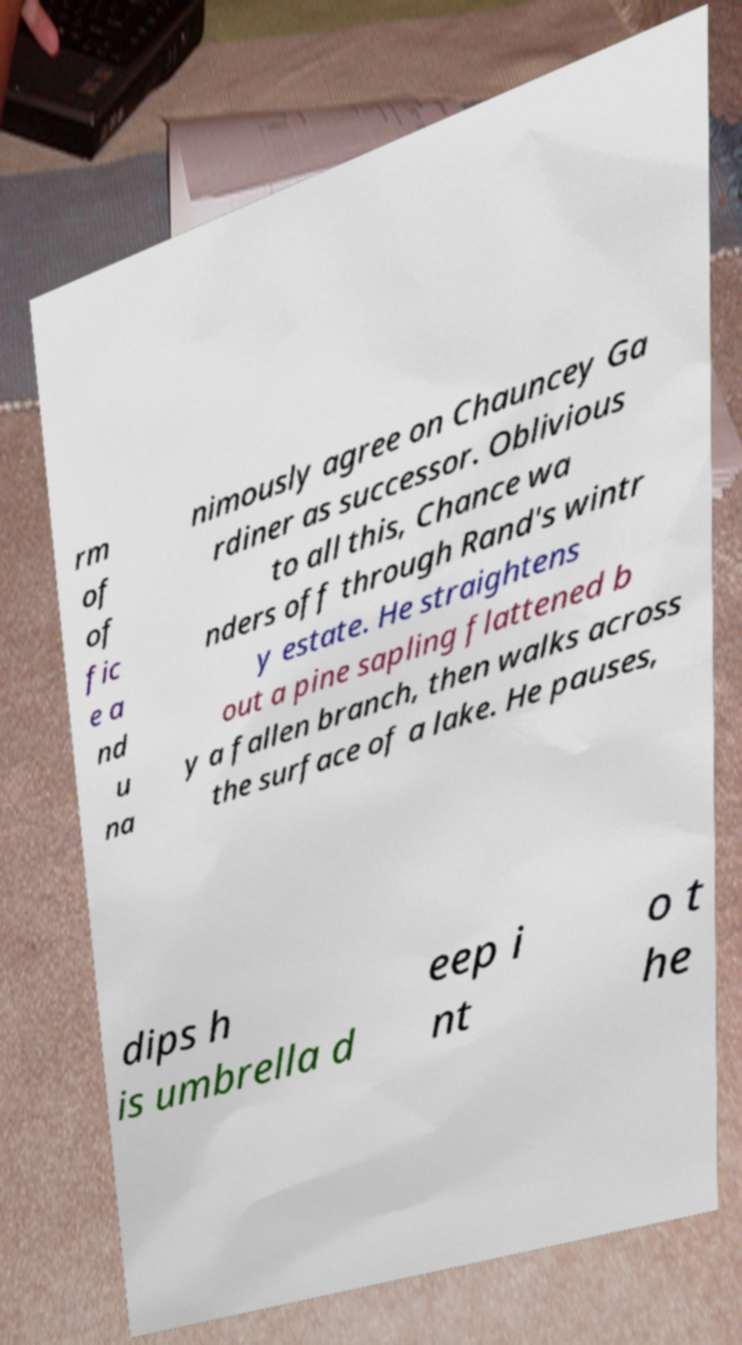For documentation purposes, I need the text within this image transcribed. Could you provide that? rm of of fic e a nd u na nimously agree on Chauncey Ga rdiner as successor. Oblivious to all this, Chance wa nders off through Rand's wintr y estate. He straightens out a pine sapling flattened b y a fallen branch, then walks across the surface of a lake. He pauses, dips h is umbrella d eep i nt o t he 